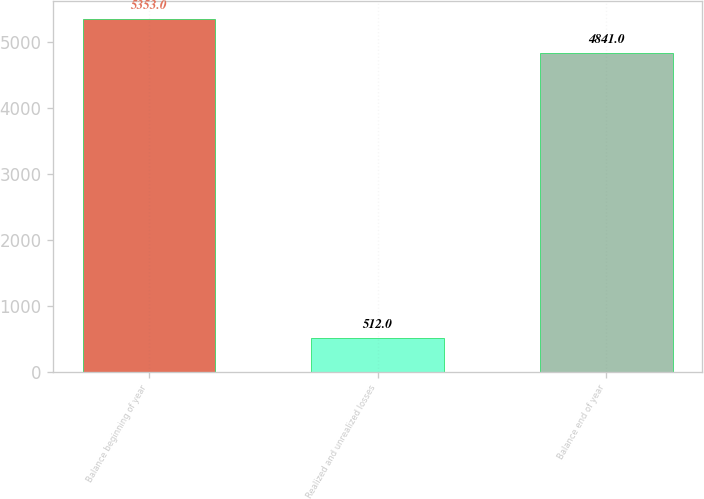<chart> <loc_0><loc_0><loc_500><loc_500><bar_chart><fcel>Balance beginning of year<fcel>Realized and unrealized losses<fcel>Balance end of year<nl><fcel>5353<fcel>512<fcel>4841<nl></chart> 